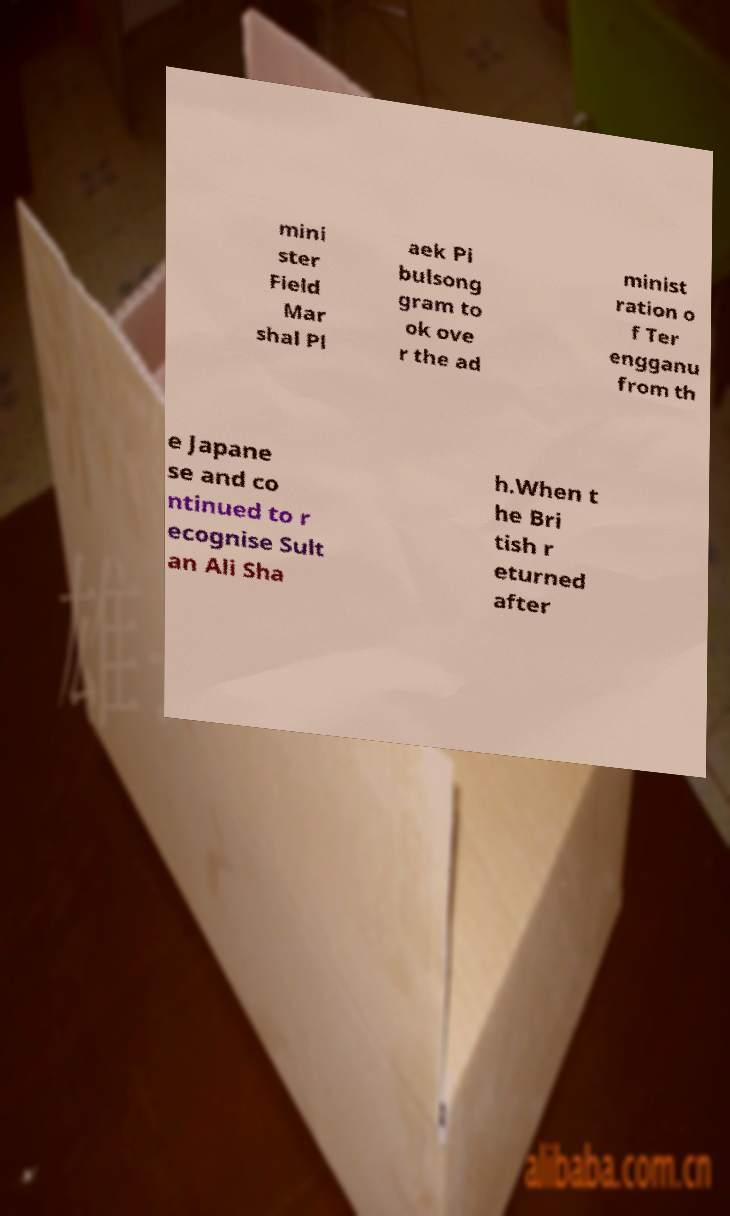Please identify and transcribe the text found in this image. mini ster Field Mar shal Pl aek Pi bulsong gram to ok ove r the ad minist ration o f Ter engganu from th e Japane se and co ntinued to r ecognise Sult an Ali Sha h.When t he Bri tish r eturned after 